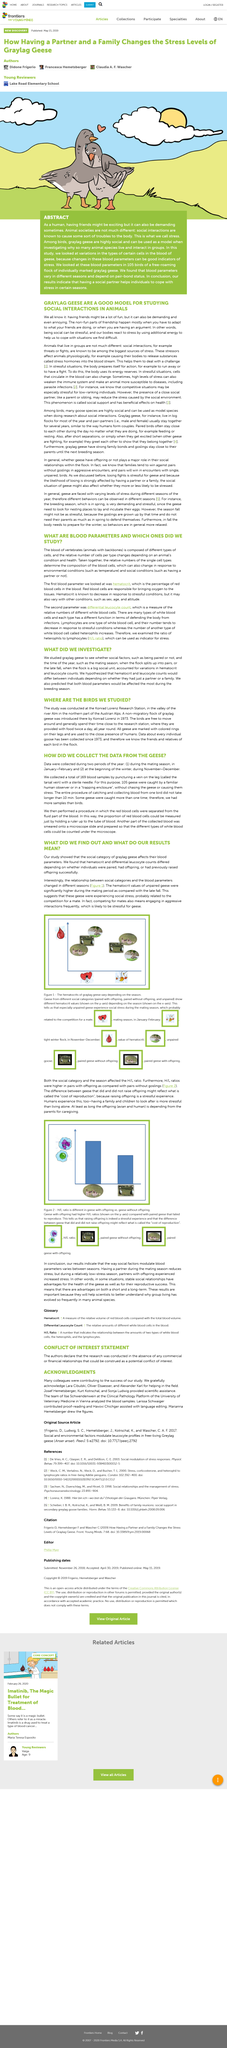Highlight a few significant elements in this photo. The birds were studied after 1973, and the study revealed that the birds were indeed studied. The study hypothesized that both blood parameters would be affected the most during the breeding season, and predicted that both blood parameters would be affected the most during the breeding season. We investigated 105 birds. The procedure of catching and collecting blood from one bird took no longer than 10 minutes. The birds are identified using colored rings on their legs. 